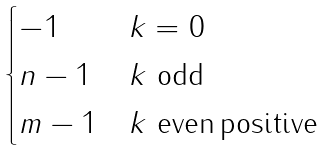<formula> <loc_0><loc_0><loc_500><loc_500>\begin{cases} - 1 & \text {$k=0$} \\ n - 1 & \text {$k$ odd} \\ m - 1 & \text {$k$ even\,positive} \\ \end{cases}</formula> 